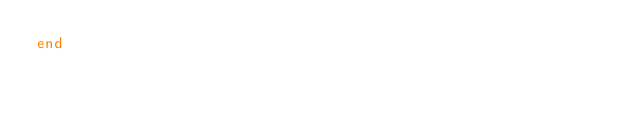Convert code to text. <code><loc_0><loc_0><loc_500><loc_500><_Ruby_>end
</code> 